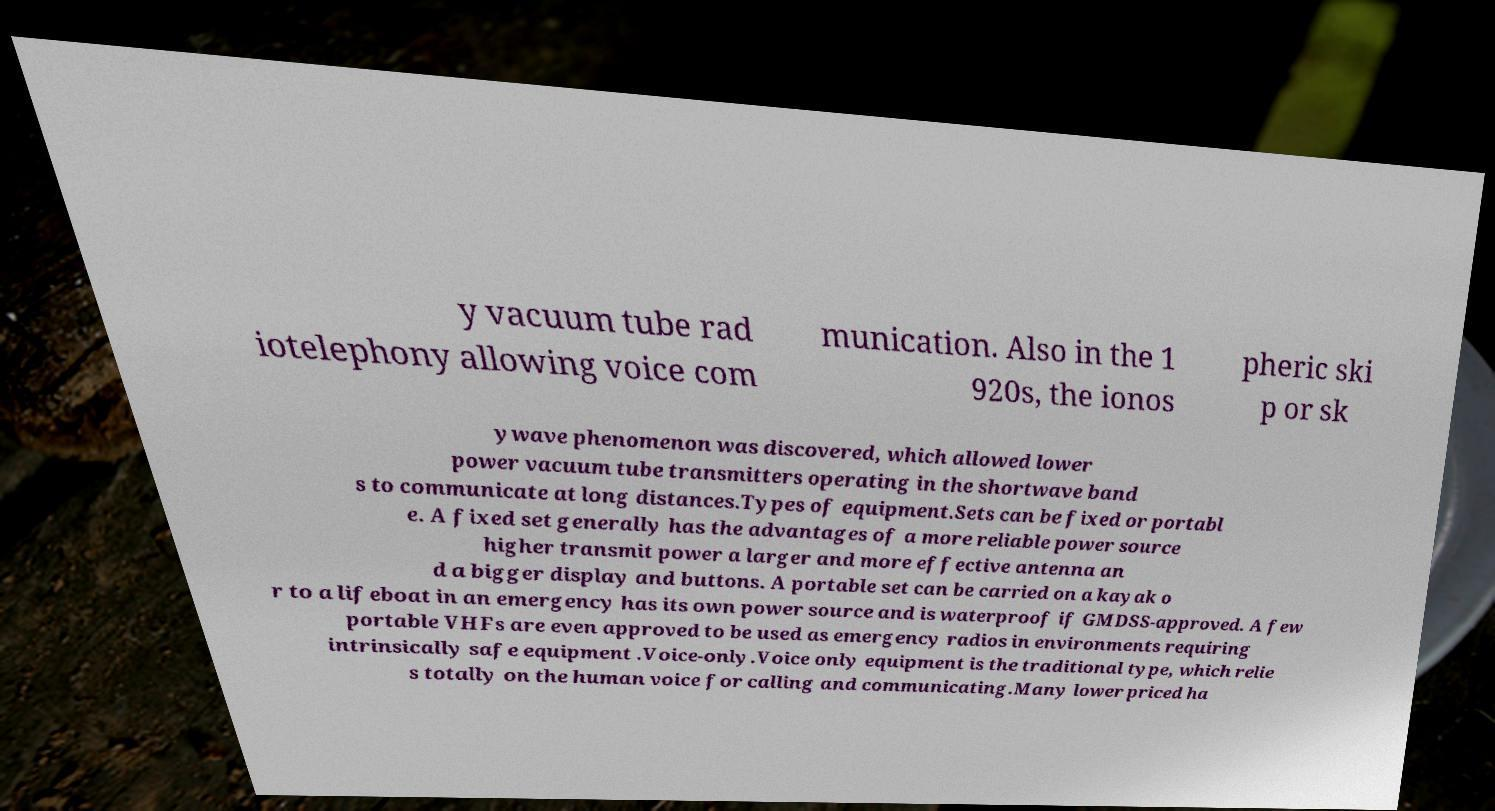Could you assist in decoding the text presented in this image and type it out clearly? y vacuum tube rad iotelephony allowing voice com munication. Also in the 1 920s, the ionos pheric ski p or sk ywave phenomenon was discovered, which allowed lower power vacuum tube transmitters operating in the shortwave band s to communicate at long distances.Types of equipment.Sets can be fixed or portabl e. A fixed set generally has the advantages of a more reliable power source higher transmit power a larger and more effective antenna an d a bigger display and buttons. A portable set can be carried on a kayak o r to a lifeboat in an emergency has its own power source and is waterproof if GMDSS-approved. A few portable VHFs are even approved to be used as emergency radios in environments requiring intrinsically safe equipment .Voice-only.Voice only equipment is the traditional type, which relie s totally on the human voice for calling and communicating.Many lower priced ha 